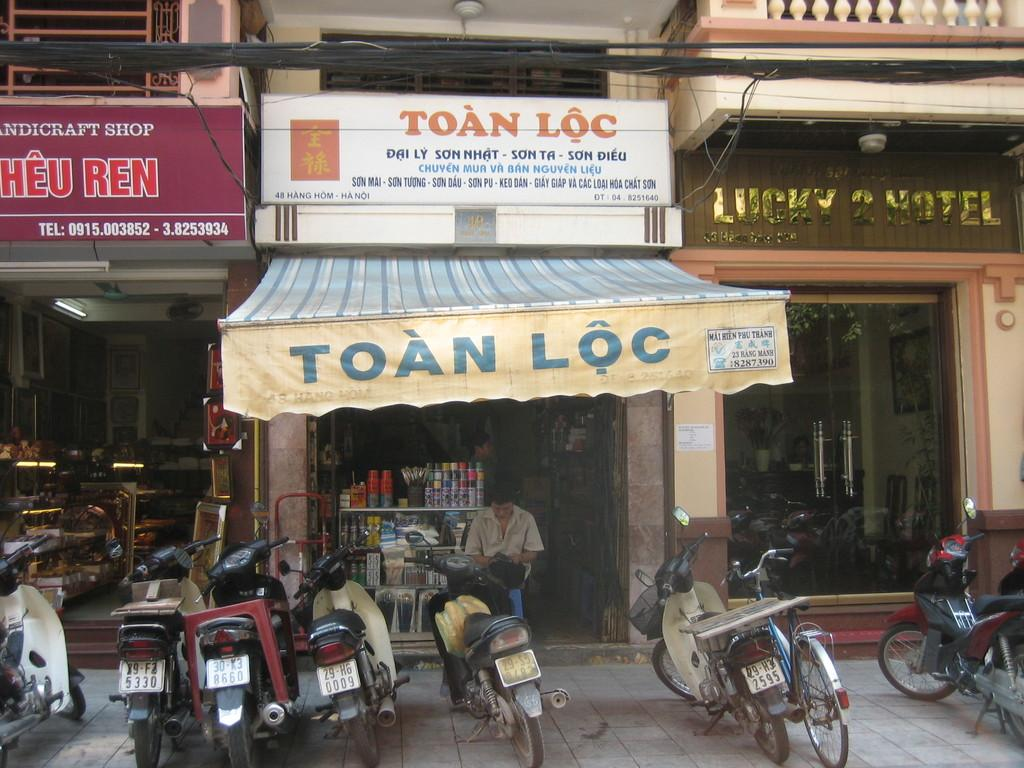What type of structure is visible in the image? There is a building present in the image. What can be found inside the building? There are stores in the building. What type of vehicles are parked in the image? Motorcycles and a bicycle are parked in the image. What is the man in the image doing? A man is seated in the image. Can you describe the man standing in the store? Another man is standing in a store in the image. What type of cream can be seen being poured into the pail in the image? There is no cream or pail present in the image. How is the knot tied on the bicycle in the image? There is no knot tied on the bicycle in the image, as it is not mentioned in the provided facts. 